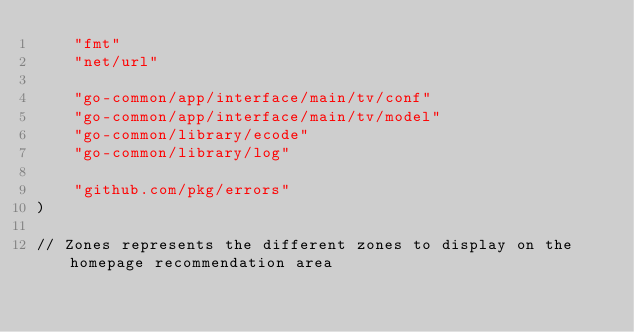<code> <loc_0><loc_0><loc_500><loc_500><_Go_>	"fmt"
	"net/url"

	"go-common/app/interface/main/tv/conf"
	"go-common/app/interface/main/tv/model"
	"go-common/library/ecode"
	"go-common/library/log"

	"github.com/pkg/errors"
)

// Zones represents the different zones to display on the homepage recommendation area</code> 